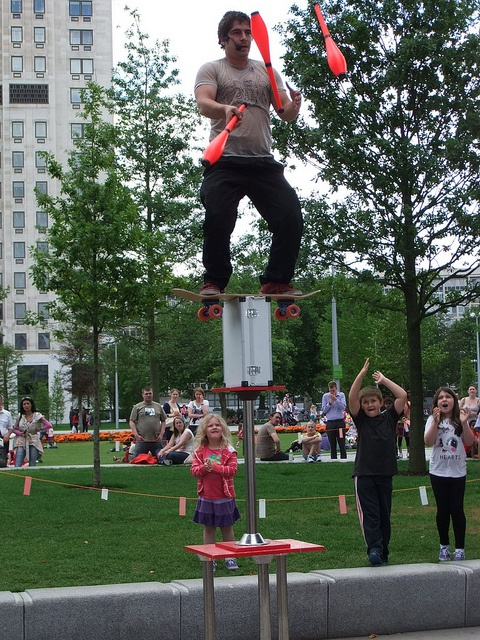Describe the objects in this image and their specific colors. I can see people in darkgray, black, gray, and maroon tones, people in darkgray, black, brown, and maroon tones, people in darkgray, black, and gray tones, people in darkgray, black, and gray tones, and people in darkgray, maroon, black, brown, and gray tones in this image. 